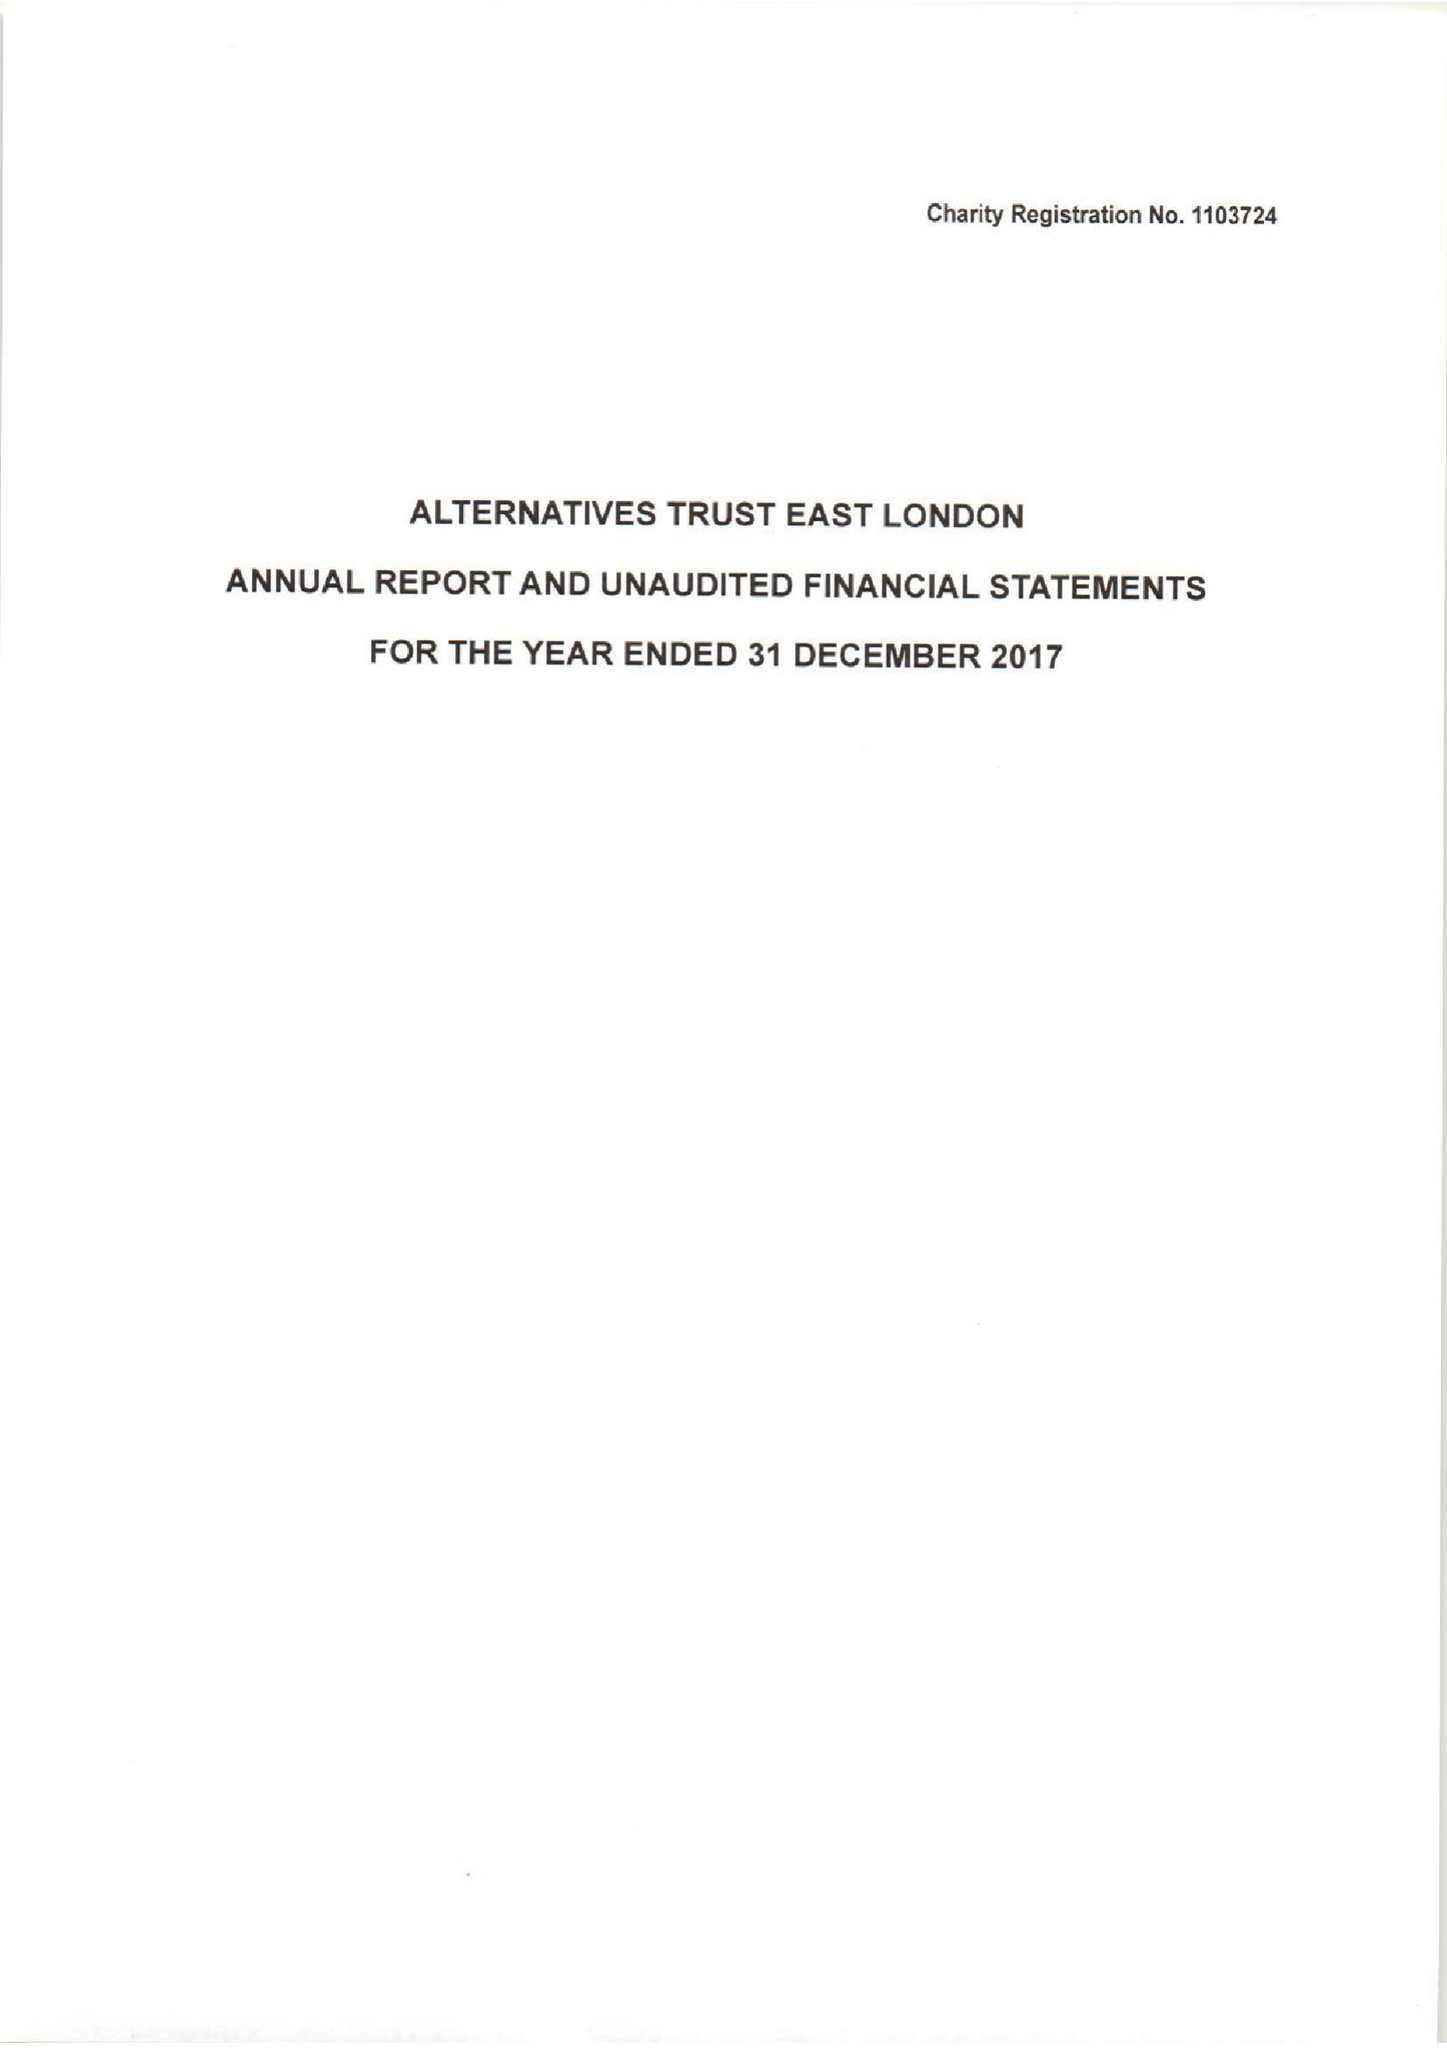What is the value for the income_annually_in_british_pounds?
Answer the question using a single word or phrase. 236667.00 